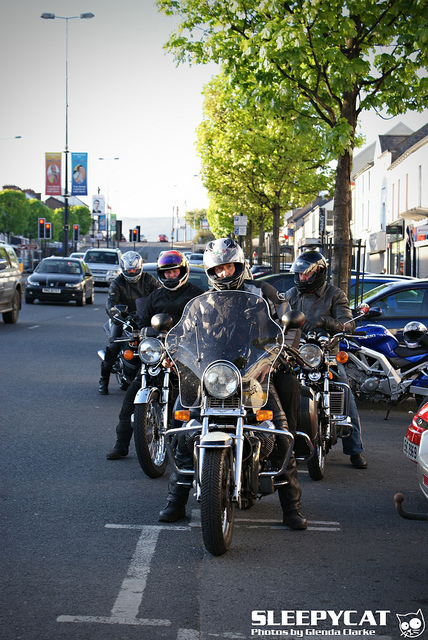Read and extract the text from this image. SLEEPLYCAT Clarke Glenda by Photos 